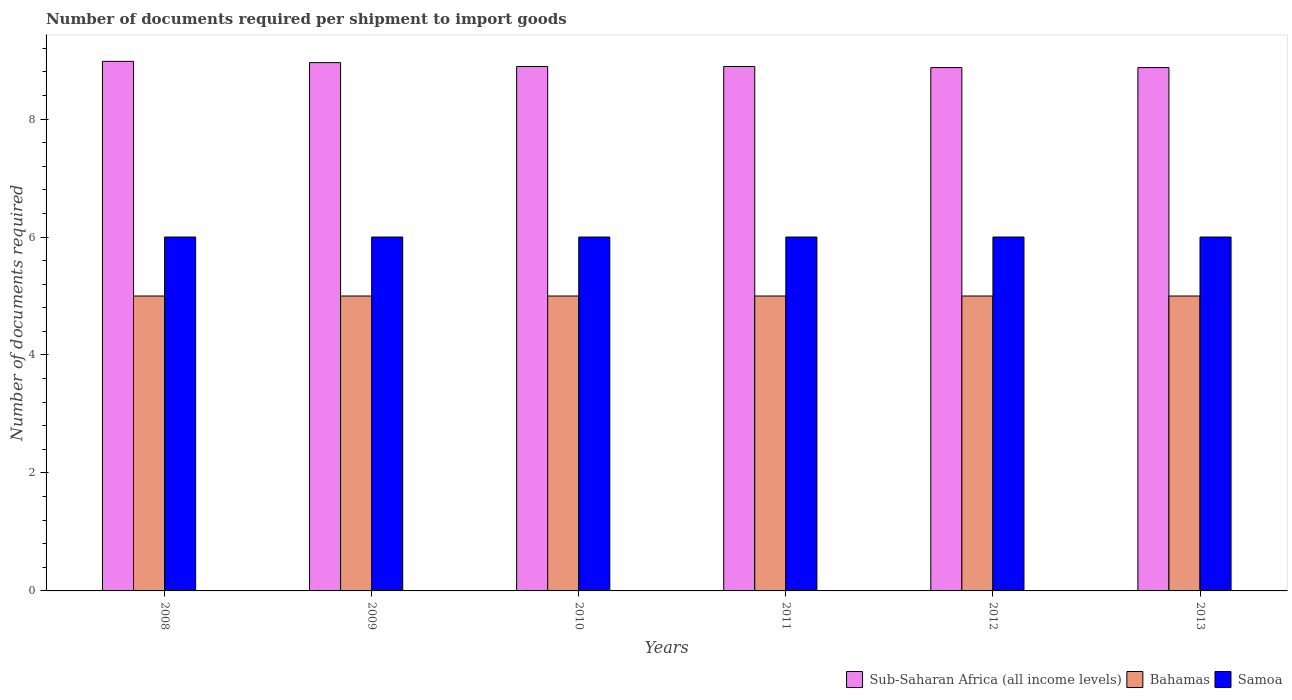How many different coloured bars are there?
Keep it short and to the point. 3. How many groups of bars are there?
Your response must be concise. 6. Are the number of bars per tick equal to the number of legend labels?
Give a very brief answer. Yes. How many bars are there on the 1st tick from the left?
Keep it short and to the point. 3. How many bars are there on the 4th tick from the right?
Give a very brief answer. 3. In how many cases, is the number of bars for a given year not equal to the number of legend labels?
Your response must be concise. 0. What is the number of documents required per shipment to import goods in Sub-Saharan Africa (all income levels) in 2008?
Offer a terse response. 8.98. Across all years, what is the maximum number of documents required per shipment to import goods in Samoa?
Offer a very short reply. 6. Across all years, what is the minimum number of documents required per shipment to import goods in Sub-Saharan Africa (all income levels)?
Offer a very short reply. 8.87. In which year was the number of documents required per shipment to import goods in Bahamas maximum?
Ensure brevity in your answer.  2008. What is the total number of documents required per shipment to import goods in Sub-Saharan Africa (all income levels) in the graph?
Give a very brief answer. 53.46. What is the difference between the number of documents required per shipment to import goods in Sub-Saharan Africa (all income levels) in 2008 and that in 2011?
Offer a terse response. 0.09. What is the difference between the number of documents required per shipment to import goods in Sub-Saharan Africa (all income levels) in 2012 and the number of documents required per shipment to import goods in Samoa in 2013?
Make the answer very short. 2.87. In the year 2010, what is the difference between the number of documents required per shipment to import goods in Bahamas and number of documents required per shipment to import goods in Samoa?
Give a very brief answer. -1. In how many years, is the number of documents required per shipment to import goods in Samoa greater than 4.4?
Provide a short and direct response. 6. What is the ratio of the number of documents required per shipment to import goods in Samoa in 2008 to that in 2009?
Give a very brief answer. 1. What is the difference between the highest and the second highest number of documents required per shipment to import goods in Sub-Saharan Africa (all income levels)?
Your answer should be very brief. 0.02. What is the difference between the highest and the lowest number of documents required per shipment to import goods in Sub-Saharan Africa (all income levels)?
Ensure brevity in your answer.  0.11. What does the 2nd bar from the left in 2010 represents?
Make the answer very short. Bahamas. What does the 1st bar from the right in 2012 represents?
Your answer should be very brief. Samoa. How many bars are there?
Your answer should be very brief. 18. How many years are there in the graph?
Keep it short and to the point. 6. What is the difference between two consecutive major ticks on the Y-axis?
Your response must be concise. 2. Does the graph contain any zero values?
Offer a very short reply. No. Does the graph contain grids?
Offer a terse response. No. How many legend labels are there?
Provide a succinct answer. 3. How are the legend labels stacked?
Give a very brief answer. Horizontal. What is the title of the graph?
Provide a short and direct response. Number of documents required per shipment to import goods. Does "Cabo Verde" appear as one of the legend labels in the graph?
Your answer should be very brief. No. What is the label or title of the Y-axis?
Make the answer very short. Number of documents required. What is the Number of documents required in Sub-Saharan Africa (all income levels) in 2008?
Provide a short and direct response. 8.98. What is the Number of documents required of Bahamas in 2008?
Your answer should be very brief. 5. What is the Number of documents required in Samoa in 2008?
Give a very brief answer. 6. What is the Number of documents required in Sub-Saharan Africa (all income levels) in 2009?
Ensure brevity in your answer.  8.96. What is the Number of documents required of Samoa in 2009?
Your response must be concise. 6. What is the Number of documents required of Sub-Saharan Africa (all income levels) in 2010?
Keep it short and to the point. 8.89. What is the Number of documents required in Bahamas in 2010?
Keep it short and to the point. 5. What is the Number of documents required in Samoa in 2010?
Offer a very short reply. 6. What is the Number of documents required of Sub-Saharan Africa (all income levels) in 2011?
Make the answer very short. 8.89. What is the Number of documents required of Samoa in 2011?
Give a very brief answer. 6. What is the Number of documents required in Sub-Saharan Africa (all income levels) in 2012?
Your answer should be very brief. 8.87. What is the Number of documents required of Samoa in 2012?
Your answer should be very brief. 6. What is the Number of documents required in Sub-Saharan Africa (all income levels) in 2013?
Keep it short and to the point. 8.87. Across all years, what is the maximum Number of documents required of Sub-Saharan Africa (all income levels)?
Provide a succinct answer. 8.98. Across all years, what is the minimum Number of documents required in Sub-Saharan Africa (all income levels)?
Give a very brief answer. 8.87. Across all years, what is the minimum Number of documents required in Samoa?
Keep it short and to the point. 6. What is the total Number of documents required in Sub-Saharan Africa (all income levels) in the graph?
Offer a very short reply. 53.46. What is the total Number of documents required in Bahamas in the graph?
Your answer should be compact. 30. What is the total Number of documents required in Samoa in the graph?
Make the answer very short. 36. What is the difference between the Number of documents required in Sub-Saharan Africa (all income levels) in 2008 and that in 2009?
Offer a very short reply. 0.02. What is the difference between the Number of documents required of Bahamas in 2008 and that in 2009?
Your answer should be compact. 0. What is the difference between the Number of documents required of Sub-Saharan Africa (all income levels) in 2008 and that in 2010?
Provide a succinct answer. 0.09. What is the difference between the Number of documents required of Bahamas in 2008 and that in 2010?
Provide a succinct answer. 0. What is the difference between the Number of documents required of Sub-Saharan Africa (all income levels) in 2008 and that in 2011?
Provide a short and direct response. 0.09. What is the difference between the Number of documents required in Bahamas in 2008 and that in 2011?
Offer a very short reply. 0. What is the difference between the Number of documents required of Samoa in 2008 and that in 2011?
Provide a succinct answer. 0. What is the difference between the Number of documents required of Sub-Saharan Africa (all income levels) in 2008 and that in 2012?
Provide a succinct answer. 0.11. What is the difference between the Number of documents required of Sub-Saharan Africa (all income levels) in 2008 and that in 2013?
Offer a very short reply. 0.11. What is the difference between the Number of documents required of Bahamas in 2008 and that in 2013?
Provide a short and direct response. 0. What is the difference between the Number of documents required of Samoa in 2008 and that in 2013?
Offer a terse response. 0. What is the difference between the Number of documents required in Sub-Saharan Africa (all income levels) in 2009 and that in 2010?
Keep it short and to the point. 0.07. What is the difference between the Number of documents required in Samoa in 2009 and that in 2010?
Provide a short and direct response. 0. What is the difference between the Number of documents required of Sub-Saharan Africa (all income levels) in 2009 and that in 2011?
Your response must be concise. 0.07. What is the difference between the Number of documents required in Bahamas in 2009 and that in 2011?
Offer a terse response. 0. What is the difference between the Number of documents required of Samoa in 2009 and that in 2011?
Your answer should be compact. 0. What is the difference between the Number of documents required of Sub-Saharan Africa (all income levels) in 2009 and that in 2012?
Give a very brief answer. 0.08. What is the difference between the Number of documents required in Samoa in 2009 and that in 2012?
Provide a short and direct response. 0. What is the difference between the Number of documents required in Sub-Saharan Africa (all income levels) in 2009 and that in 2013?
Offer a terse response. 0.08. What is the difference between the Number of documents required of Samoa in 2009 and that in 2013?
Give a very brief answer. 0. What is the difference between the Number of documents required in Bahamas in 2010 and that in 2011?
Your answer should be very brief. 0. What is the difference between the Number of documents required in Sub-Saharan Africa (all income levels) in 2010 and that in 2012?
Your response must be concise. 0.02. What is the difference between the Number of documents required in Sub-Saharan Africa (all income levels) in 2010 and that in 2013?
Offer a very short reply. 0.02. What is the difference between the Number of documents required of Sub-Saharan Africa (all income levels) in 2011 and that in 2012?
Your answer should be very brief. 0.02. What is the difference between the Number of documents required in Sub-Saharan Africa (all income levels) in 2011 and that in 2013?
Provide a succinct answer. 0.02. What is the difference between the Number of documents required of Bahamas in 2012 and that in 2013?
Your response must be concise. 0. What is the difference between the Number of documents required of Samoa in 2012 and that in 2013?
Make the answer very short. 0. What is the difference between the Number of documents required of Sub-Saharan Africa (all income levels) in 2008 and the Number of documents required of Bahamas in 2009?
Your response must be concise. 3.98. What is the difference between the Number of documents required of Sub-Saharan Africa (all income levels) in 2008 and the Number of documents required of Samoa in 2009?
Your response must be concise. 2.98. What is the difference between the Number of documents required in Bahamas in 2008 and the Number of documents required in Samoa in 2009?
Your answer should be very brief. -1. What is the difference between the Number of documents required of Sub-Saharan Africa (all income levels) in 2008 and the Number of documents required of Bahamas in 2010?
Your answer should be very brief. 3.98. What is the difference between the Number of documents required of Sub-Saharan Africa (all income levels) in 2008 and the Number of documents required of Samoa in 2010?
Offer a very short reply. 2.98. What is the difference between the Number of documents required of Sub-Saharan Africa (all income levels) in 2008 and the Number of documents required of Bahamas in 2011?
Your response must be concise. 3.98. What is the difference between the Number of documents required of Sub-Saharan Africa (all income levels) in 2008 and the Number of documents required of Samoa in 2011?
Give a very brief answer. 2.98. What is the difference between the Number of documents required of Bahamas in 2008 and the Number of documents required of Samoa in 2011?
Ensure brevity in your answer.  -1. What is the difference between the Number of documents required of Sub-Saharan Africa (all income levels) in 2008 and the Number of documents required of Bahamas in 2012?
Your response must be concise. 3.98. What is the difference between the Number of documents required of Sub-Saharan Africa (all income levels) in 2008 and the Number of documents required of Samoa in 2012?
Make the answer very short. 2.98. What is the difference between the Number of documents required of Bahamas in 2008 and the Number of documents required of Samoa in 2012?
Ensure brevity in your answer.  -1. What is the difference between the Number of documents required in Sub-Saharan Africa (all income levels) in 2008 and the Number of documents required in Bahamas in 2013?
Provide a short and direct response. 3.98. What is the difference between the Number of documents required in Sub-Saharan Africa (all income levels) in 2008 and the Number of documents required in Samoa in 2013?
Make the answer very short. 2.98. What is the difference between the Number of documents required in Bahamas in 2008 and the Number of documents required in Samoa in 2013?
Ensure brevity in your answer.  -1. What is the difference between the Number of documents required in Sub-Saharan Africa (all income levels) in 2009 and the Number of documents required in Bahamas in 2010?
Your answer should be compact. 3.96. What is the difference between the Number of documents required of Sub-Saharan Africa (all income levels) in 2009 and the Number of documents required of Samoa in 2010?
Provide a succinct answer. 2.96. What is the difference between the Number of documents required in Bahamas in 2009 and the Number of documents required in Samoa in 2010?
Provide a short and direct response. -1. What is the difference between the Number of documents required in Sub-Saharan Africa (all income levels) in 2009 and the Number of documents required in Bahamas in 2011?
Offer a very short reply. 3.96. What is the difference between the Number of documents required in Sub-Saharan Africa (all income levels) in 2009 and the Number of documents required in Samoa in 2011?
Make the answer very short. 2.96. What is the difference between the Number of documents required in Bahamas in 2009 and the Number of documents required in Samoa in 2011?
Keep it short and to the point. -1. What is the difference between the Number of documents required of Sub-Saharan Africa (all income levels) in 2009 and the Number of documents required of Bahamas in 2012?
Provide a succinct answer. 3.96. What is the difference between the Number of documents required in Sub-Saharan Africa (all income levels) in 2009 and the Number of documents required in Samoa in 2012?
Offer a terse response. 2.96. What is the difference between the Number of documents required of Sub-Saharan Africa (all income levels) in 2009 and the Number of documents required of Bahamas in 2013?
Provide a succinct answer. 3.96. What is the difference between the Number of documents required in Sub-Saharan Africa (all income levels) in 2009 and the Number of documents required in Samoa in 2013?
Your response must be concise. 2.96. What is the difference between the Number of documents required in Bahamas in 2009 and the Number of documents required in Samoa in 2013?
Offer a very short reply. -1. What is the difference between the Number of documents required in Sub-Saharan Africa (all income levels) in 2010 and the Number of documents required in Bahamas in 2011?
Make the answer very short. 3.89. What is the difference between the Number of documents required of Sub-Saharan Africa (all income levels) in 2010 and the Number of documents required of Samoa in 2011?
Provide a succinct answer. 2.89. What is the difference between the Number of documents required in Sub-Saharan Africa (all income levels) in 2010 and the Number of documents required in Bahamas in 2012?
Give a very brief answer. 3.89. What is the difference between the Number of documents required in Sub-Saharan Africa (all income levels) in 2010 and the Number of documents required in Samoa in 2012?
Provide a succinct answer. 2.89. What is the difference between the Number of documents required in Sub-Saharan Africa (all income levels) in 2010 and the Number of documents required in Bahamas in 2013?
Your answer should be very brief. 3.89. What is the difference between the Number of documents required of Sub-Saharan Africa (all income levels) in 2010 and the Number of documents required of Samoa in 2013?
Give a very brief answer. 2.89. What is the difference between the Number of documents required of Bahamas in 2010 and the Number of documents required of Samoa in 2013?
Offer a very short reply. -1. What is the difference between the Number of documents required in Sub-Saharan Africa (all income levels) in 2011 and the Number of documents required in Bahamas in 2012?
Keep it short and to the point. 3.89. What is the difference between the Number of documents required of Sub-Saharan Africa (all income levels) in 2011 and the Number of documents required of Samoa in 2012?
Your response must be concise. 2.89. What is the difference between the Number of documents required in Sub-Saharan Africa (all income levels) in 2011 and the Number of documents required in Bahamas in 2013?
Your response must be concise. 3.89. What is the difference between the Number of documents required in Sub-Saharan Africa (all income levels) in 2011 and the Number of documents required in Samoa in 2013?
Your answer should be compact. 2.89. What is the difference between the Number of documents required in Sub-Saharan Africa (all income levels) in 2012 and the Number of documents required in Bahamas in 2013?
Your response must be concise. 3.87. What is the difference between the Number of documents required in Sub-Saharan Africa (all income levels) in 2012 and the Number of documents required in Samoa in 2013?
Your answer should be compact. 2.87. What is the difference between the Number of documents required in Bahamas in 2012 and the Number of documents required in Samoa in 2013?
Your response must be concise. -1. What is the average Number of documents required in Sub-Saharan Africa (all income levels) per year?
Give a very brief answer. 8.91. What is the average Number of documents required of Bahamas per year?
Keep it short and to the point. 5. What is the average Number of documents required of Samoa per year?
Your answer should be very brief. 6. In the year 2008, what is the difference between the Number of documents required in Sub-Saharan Africa (all income levels) and Number of documents required in Bahamas?
Your response must be concise. 3.98. In the year 2008, what is the difference between the Number of documents required in Sub-Saharan Africa (all income levels) and Number of documents required in Samoa?
Make the answer very short. 2.98. In the year 2008, what is the difference between the Number of documents required in Bahamas and Number of documents required in Samoa?
Your answer should be very brief. -1. In the year 2009, what is the difference between the Number of documents required of Sub-Saharan Africa (all income levels) and Number of documents required of Bahamas?
Your answer should be compact. 3.96. In the year 2009, what is the difference between the Number of documents required of Sub-Saharan Africa (all income levels) and Number of documents required of Samoa?
Offer a terse response. 2.96. In the year 2010, what is the difference between the Number of documents required of Sub-Saharan Africa (all income levels) and Number of documents required of Bahamas?
Provide a succinct answer. 3.89. In the year 2010, what is the difference between the Number of documents required of Sub-Saharan Africa (all income levels) and Number of documents required of Samoa?
Make the answer very short. 2.89. In the year 2011, what is the difference between the Number of documents required in Sub-Saharan Africa (all income levels) and Number of documents required in Bahamas?
Offer a terse response. 3.89. In the year 2011, what is the difference between the Number of documents required in Sub-Saharan Africa (all income levels) and Number of documents required in Samoa?
Make the answer very short. 2.89. In the year 2011, what is the difference between the Number of documents required of Bahamas and Number of documents required of Samoa?
Your response must be concise. -1. In the year 2012, what is the difference between the Number of documents required of Sub-Saharan Africa (all income levels) and Number of documents required of Bahamas?
Keep it short and to the point. 3.87. In the year 2012, what is the difference between the Number of documents required in Sub-Saharan Africa (all income levels) and Number of documents required in Samoa?
Your answer should be very brief. 2.87. In the year 2012, what is the difference between the Number of documents required of Bahamas and Number of documents required of Samoa?
Provide a succinct answer. -1. In the year 2013, what is the difference between the Number of documents required of Sub-Saharan Africa (all income levels) and Number of documents required of Bahamas?
Give a very brief answer. 3.87. In the year 2013, what is the difference between the Number of documents required of Sub-Saharan Africa (all income levels) and Number of documents required of Samoa?
Provide a succinct answer. 2.87. In the year 2013, what is the difference between the Number of documents required in Bahamas and Number of documents required in Samoa?
Keep it short and to the point. -1. What is the ratio of the Number of documents required in Sub-Saharan Africa (all income levels) in 2008 to that in 2009?
Offer a terse response. 1. What is the ratio of the Number of documents required of Samoa in 2008 to that in 2009?
Provide a succinct answer. 1. What is the ratio of the Number of documents required of Sub-Saharan Africa (all income levels) in 2008 to that in 2010?
Ensure brevity in your answer.  1.01. What is the ratio of the Number of documents required of Sub-Saharan Africa (all income levels) in 2008 to that in 2011?
Your answer should be very brief. 1.01. What is the ratio of the Number of documents required of Samoa in 2008 to that in 2011?
Offer a very short reply. 1. What is the ratio of the Number of documents required of Sub-Saharan Africa (all income levels) in 2008 to that in 2012?
Give a very brief answer. 1.01. What is the ratio of the Number of documents required of Samoa in 2008 to that in 2012?
Offer a very short reply. 1. What is the ratio of the Number of documents required of Sub-Saharan Africa (all income levels) in 2008 to that in 2013?
Your answer should be very brief. 1.01. What is the ratio of the Number of documents required in Bahamas in 2008 to that in 2013?
Provide a short and direct response. 1. What is the ratio of the Number of documents required of Samoa in 2008 to that in 2013?
Make the answer very short. 1. What is the ratio of the Number of documents required of Sub-Saharan Africa (all income levels) in 2009 to that in 2010?
Provide a succinct answer. 1.01. What is the ratio of the Number of documents required in Bahamas in 2009 to that in 2010?
Ensure brevity in your answer.  1. What is the ratio of the Number of documents required of Sub-Saharan Africa (all income levels) in 2009 to that in 2011?
Offer a terse response. 1.01. What is the ratio of the Number of documents required in Samoa in 2009 to that in 2011?
Your response must be concise. 1. What is the ratio of the Number of documents required in Sub-Saharan Africa (all income levels) in 2009 to that in 2012?
Your answer should be very brief. 1.01. What is the ratio of the Number of documents required of Bahamas in 2009 to that in 2012?
Ensure brevity in your answer.  1. What is the ratio of the Number of documents required of Samoa in 2009 to that in 2012?
Keep it short and to the point. 1. What is the ratio of the Number of documents required of Sub-Saharan Africa (all income levels) in 2009 to that in 2013?
Provide a succinct answer. 1.01. What is the ratio of the Number of documents required of Samoa in 2009 to that in 2013?
Make the answer very short. 1. What is the ratio of the Number of documents required in Sub-Saharan Africa (all income levels) in 2010 to that in 2011?
Provide a short and direct response. 1. What is the ratio of the Number of documents required in Samoa in 2010 to that in 2011?
Provide a short and direct response. 1. What is the ratio of the Number of documents required of Bahamas in 2010 to that in 2012?
Offer a terse response. 1. What is the ratio of the Number of documents required in Sub-Saharan Africa (all income levels) in 2011 to that in 2012?
Your answer should be compact. 1. What is the ratio of the Number of documents required of Bahamas in 2011 to that in 2012?
Make the answer very short. 1. What is the ratio of the Number of documents required in Samoa in 2011 to that in 2012?
Offer a very short reply. 1. What is the ratio of the Number of documents required in Sub-Saharan Africa (all income levels) in 2011 to that in 2013?
Your response must be concise. 1. What is the ratio of the Number of documents required in Bahamas in 2011 to that in 2013?
Your answer should be very brief. 1. What is the ratio of the Number of documents required in Samoa in 2011 to that in 2013?
Your response must be concise. 1. What is the ratio of the Number of documents required of Bahamas in 2012 to that in 2013?
Offer a terse response. 1. What is the difference between the highest and the second highest Number of documents required of Sub-Saharan Africa (all income levels)?
Provide a succinct answer. 0.02. What is the difference between the highest and the second highest Number of documents required in Samoa?
Your answer should be compact. 0. What is the difference between the highest and the lowest Number of documents required in Sub-Saharan Africa (all income levels)?
Offer a terse response. 0.11. 